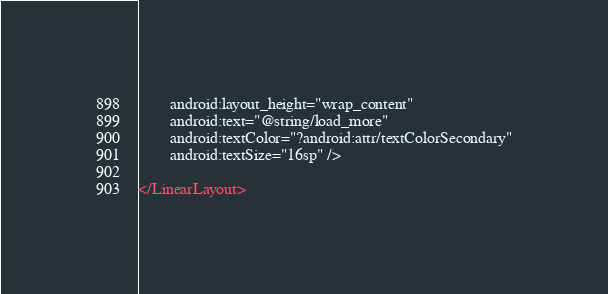<code> <loc_0><loc_0><loc_500><loc_500><_XML_>        android:layout_height="wrap_content"
        android:text="@string/load_more"
        android:textColor="?android:attr/textColorSecondary"
        android:textSize="16sp" />

</LinearLayout>
</code> 